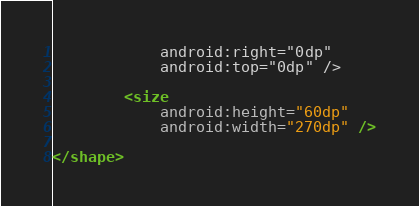<code> <loc_0><loc_0><loc_500><loc_500><_XML_>            android:right="0dp"
            android:top="0dp" />

        <size
            android:height="60dp"
            android:width="270dp" />

</shape>
</code> 